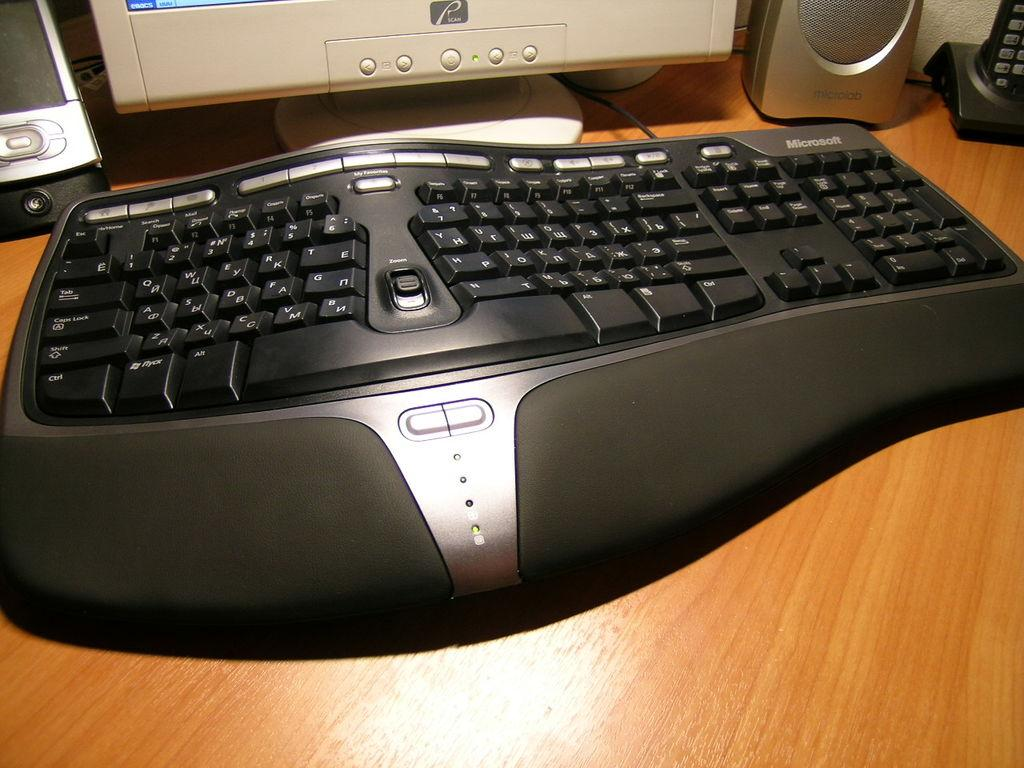<image>
Present a compact description of the photo's key features. A computer keyboard has the Microsoft name on the top right. 